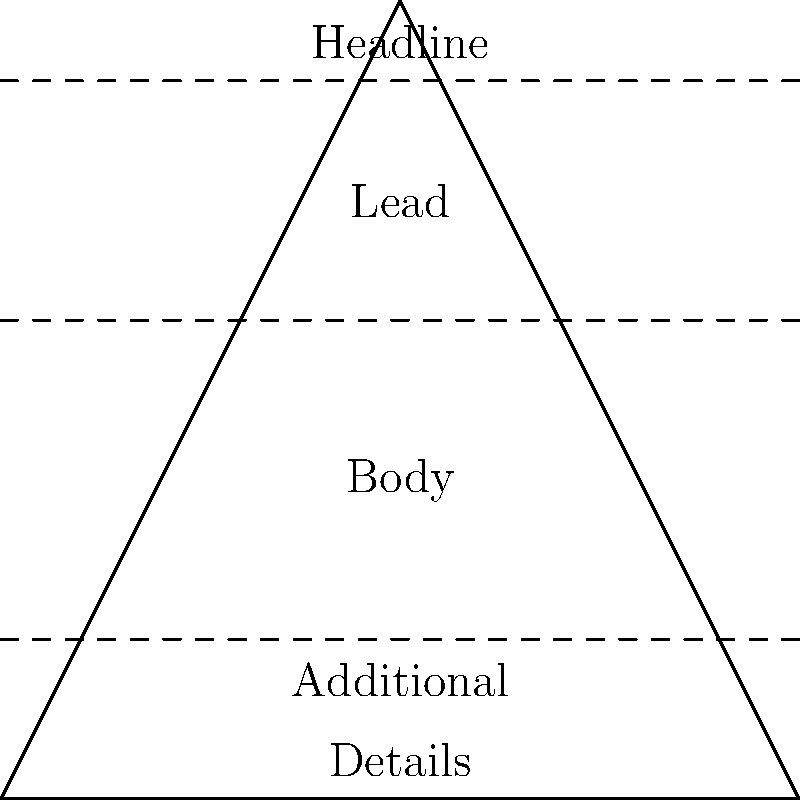In the inverted pyramid structure of a news article, which element should contain the most essential information and appear at the top of the article? The inverted pyramid structure is a fundamental concept in journalism, designed to present information in order of importance. Here's a step-by-step breakdown of the structure:

1. The pyramid is "inverted" because the most crucial information is at the top, with less important details following.

2. The structure typically consists of four main parts:
   a) Headline
   b) Lead (or Lede)
   c) Body
   d) Additional Details

3. The Headline is at the very top, meant to grab attention and summarize the main point.

4. The Lead follows immediately after the headline. It's the first paragraph of the article and contains the most critical information.

5. The Lead answers the five W's (Who, What, When, Where, Why) and sometimes How.

6. The Body provides more context and details, expanding on the information in the Lead.

7. Additional Details come last, offering background information or less crucial facts.

8. This structure allows readers to quickly grasp the main points of the story, even if they don't read the entire article.

9. In the diagram, the Lead is positioned at the top of the pyramid body, just below the Headline, indicating its importance in conveying essential information.

Therefore, based on this structure, the Lead should contain the most essential information and appear at the top of the article, right after the Headline.
Answer: Lead 